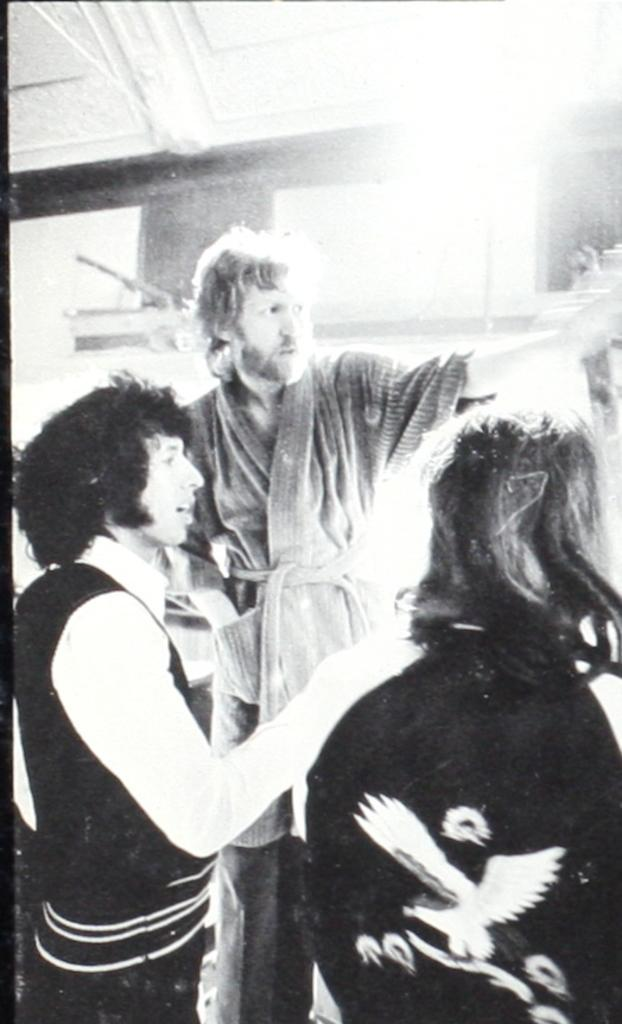How many people are in the image? There are three persons in the image. What can be said about the color scheme of the image? The image is in black and white color. What type of arch can be seen in the image? There is no arch present in the image; it only features three persons in a black and white setting. 